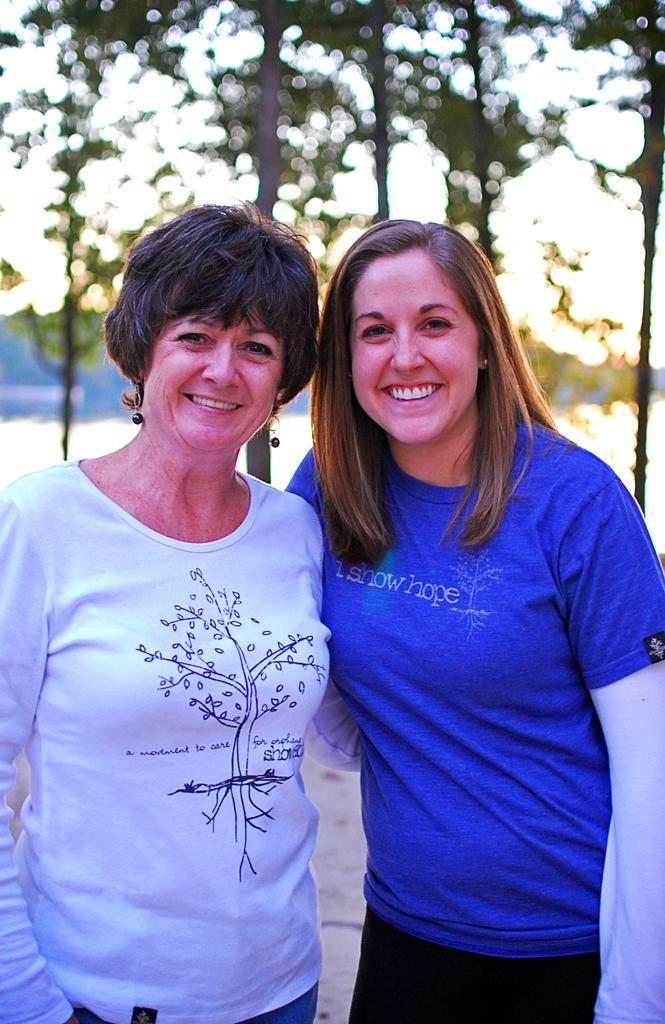Could you give a brief overview of what you see in this image? In this picture we can see two women smiling, standing and at the back of them we can see trees and it is blurry. 